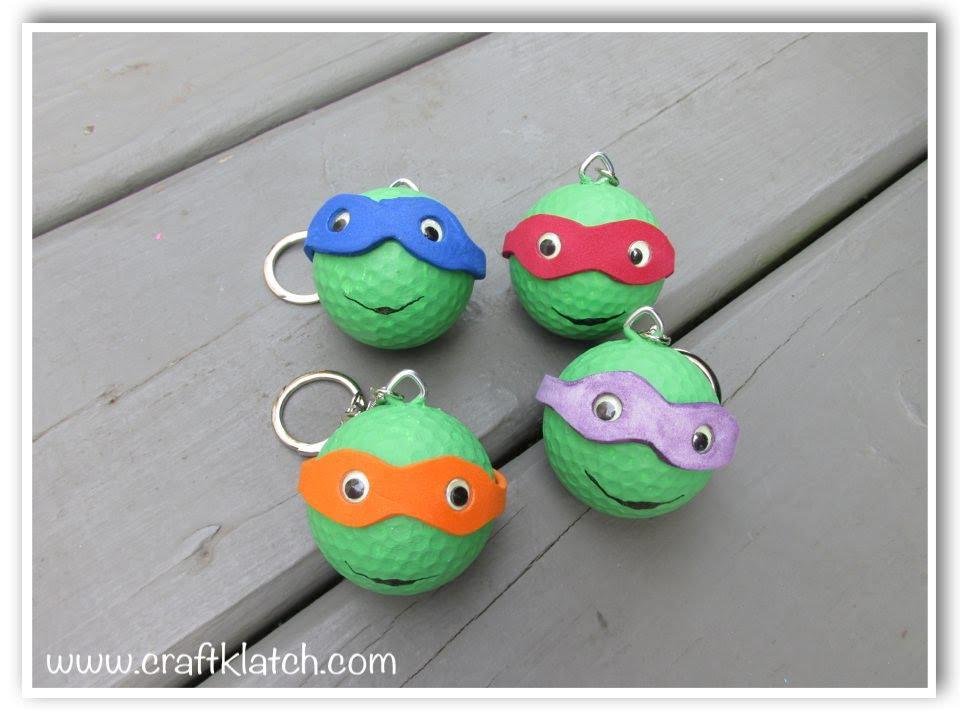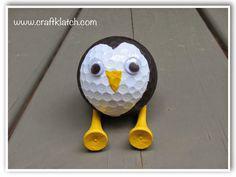The first image is the image on the left, the second image is the image on the right. Assess this claim about the two images: "At least one of the images feature a six golf balls arranged in a shape.". Correct or not? Answer yes or no. No. The first image is the image on the left, the second image is the image on the right. Analyze the images presented: Is the assertion "Exactly four balls are posed close together in one image, and all balls have the same surface color." valid? Answer yes or no. Yes. 